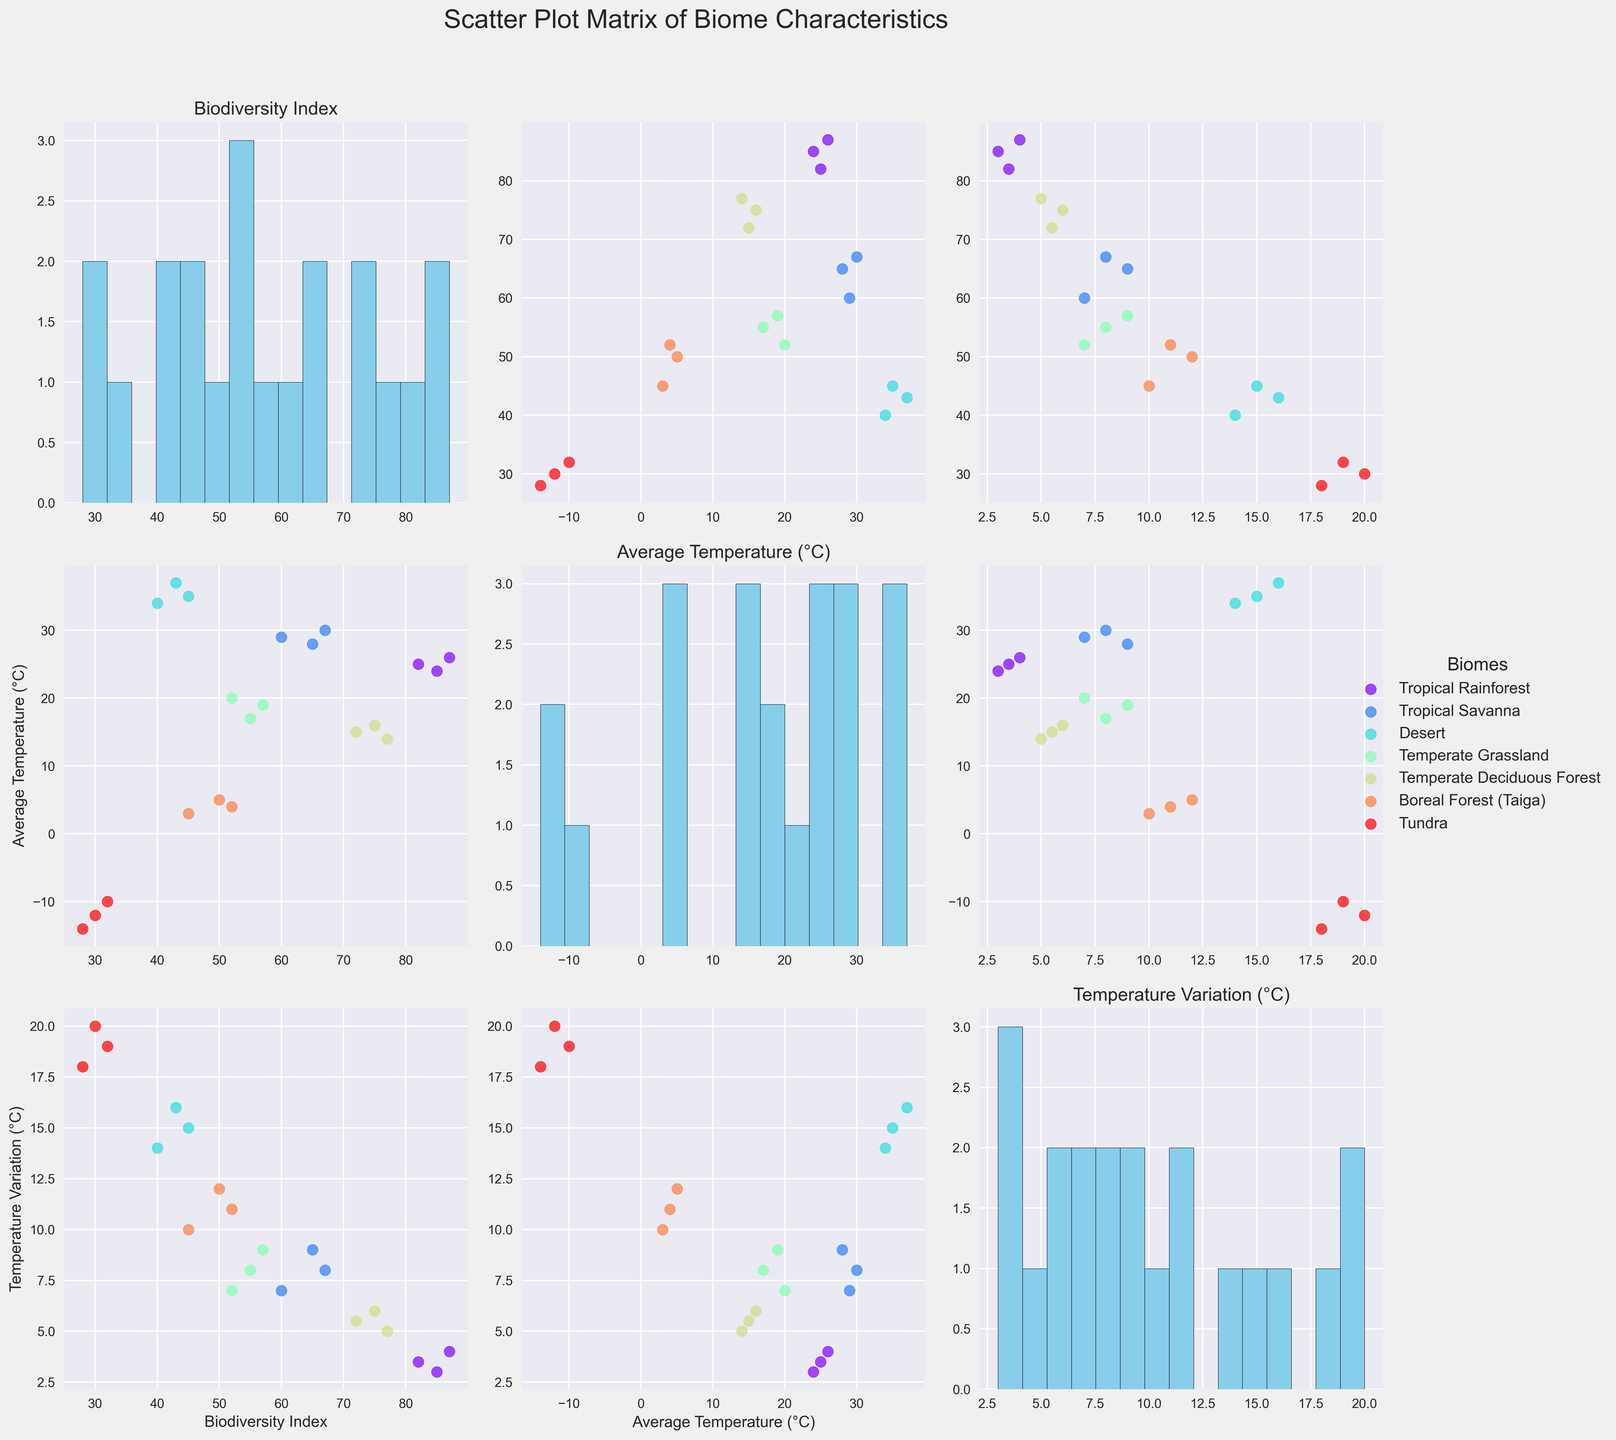What's the title of the figure? The figure's title is found at the top center of the plot. It helps to understand the overall theme. The title is "Scatter Plot Matrix of Biome Characteristics".
Answer: Scatter Plot Matrix of Biome Characteristics Which biome has the highest average biodiversity index? By looking at the scatter plots of Biodiversity Index against other features, or the histograms, we can see that the Tropical Rainforest biome has the highest biodiversity index values.
Answer: Tropical Rainforest What is the range of average temperatures observed in the Desert biome? In the scatter plots where the x-axis is 'Average Temperature (°C)' and the color representing 'Desert', we can see the range by identifying the lowest and highest plotted points for 'Desert'. The range is from 34°C to 37°C.
Answer: 34-37°C Which biome exhibits the highest temperature variation? In the scatter plots and histograms where the axis is 'Temperature Variation (°C)', the largest values and range for 'Tundra' indicate the highest temperature variation. This is verifiable by identifying the highest data points plotted for 'Tundra'.
Answer: Tundra How does the biodiversity index relate to temperature variation in the Temperate Deciduous Forest? Looking at the scatter plot specifically for Temperate Deciduous Forest, we plot Biodiversity Index against Temperature Variation and, with a pairwise comparison, observe that as temperature variation increases slightly, biodiversity remains relatively high and stable. The relationship appears weak or slightly positive.
Answer: Weak or slightly positive In which biome is the variance in the Biodiversity Index the smallest? This can be observed from the histograms of Biodiversity Index for different biomes, and identifying which biome has the narrowest spread of values. Temperate Deciduous Forest shows the smallest variance.
Answer: Temperate Deciduous Forest Which biomes fall between 10°C and 20°C in average temperature? By inspecting the scatter plots and histograms with 'Average Temperature (°C)' as the attribute, the points or ranges falling within 10-20°C belong to Temperate Grassland and Temperate Deciduous Forest.
Answer: Temperate Grassland, Temperate Deciduous Forest Comparing Tropical Savanna and Boreal Forest (Taiga), which biome tends to have higher temperature variations? Observing the scatter plots discussing 'Temperature Variation (°C)', and comparing the color-coded points of 'Tropical Savanna' and 'Boreal Forest (Taiga)', the Boreal Forest (Taiga) exhibits higher temperature variations, as evidenced by higher values on the corresponding axis.
Answer: Boreal Forest (Taiga) Is there any biome that shows a direct proportional relationship between average temperature and biodiversity index? Analyzing scatter plots of 'Average Temperature (°C)' versus 'Biodiversity Index', if the points form a line or a clear trend, it indicates proportionality. None of the biomes show such a direct proportional relationship strictly; however, Tropical Rainforest shows some positive correlation but not strictly proportional.
Answer: No strict proportional relationship 